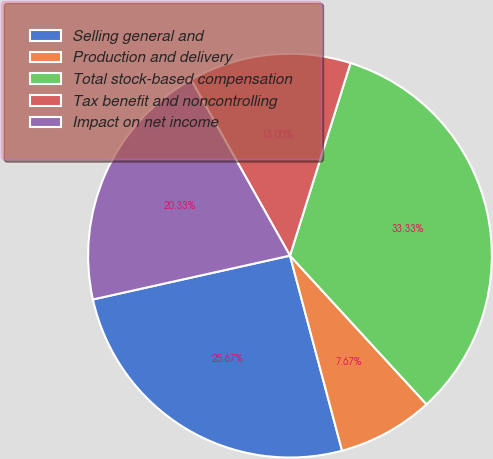<chart> <loc_0><loc_0><loc_500><loc_500><pie_chart><fcel>Selling general and<fcel>Production and delivery<fcel>Total stock-based compensation<fcel>Tax benefit and noncontrolling<fcel>Impact on net income<nl><fcel>25.67%<fcel>7.67%<fcel>33.33%<fcel>13.0%<fcel>20.33%<nl></chart> 